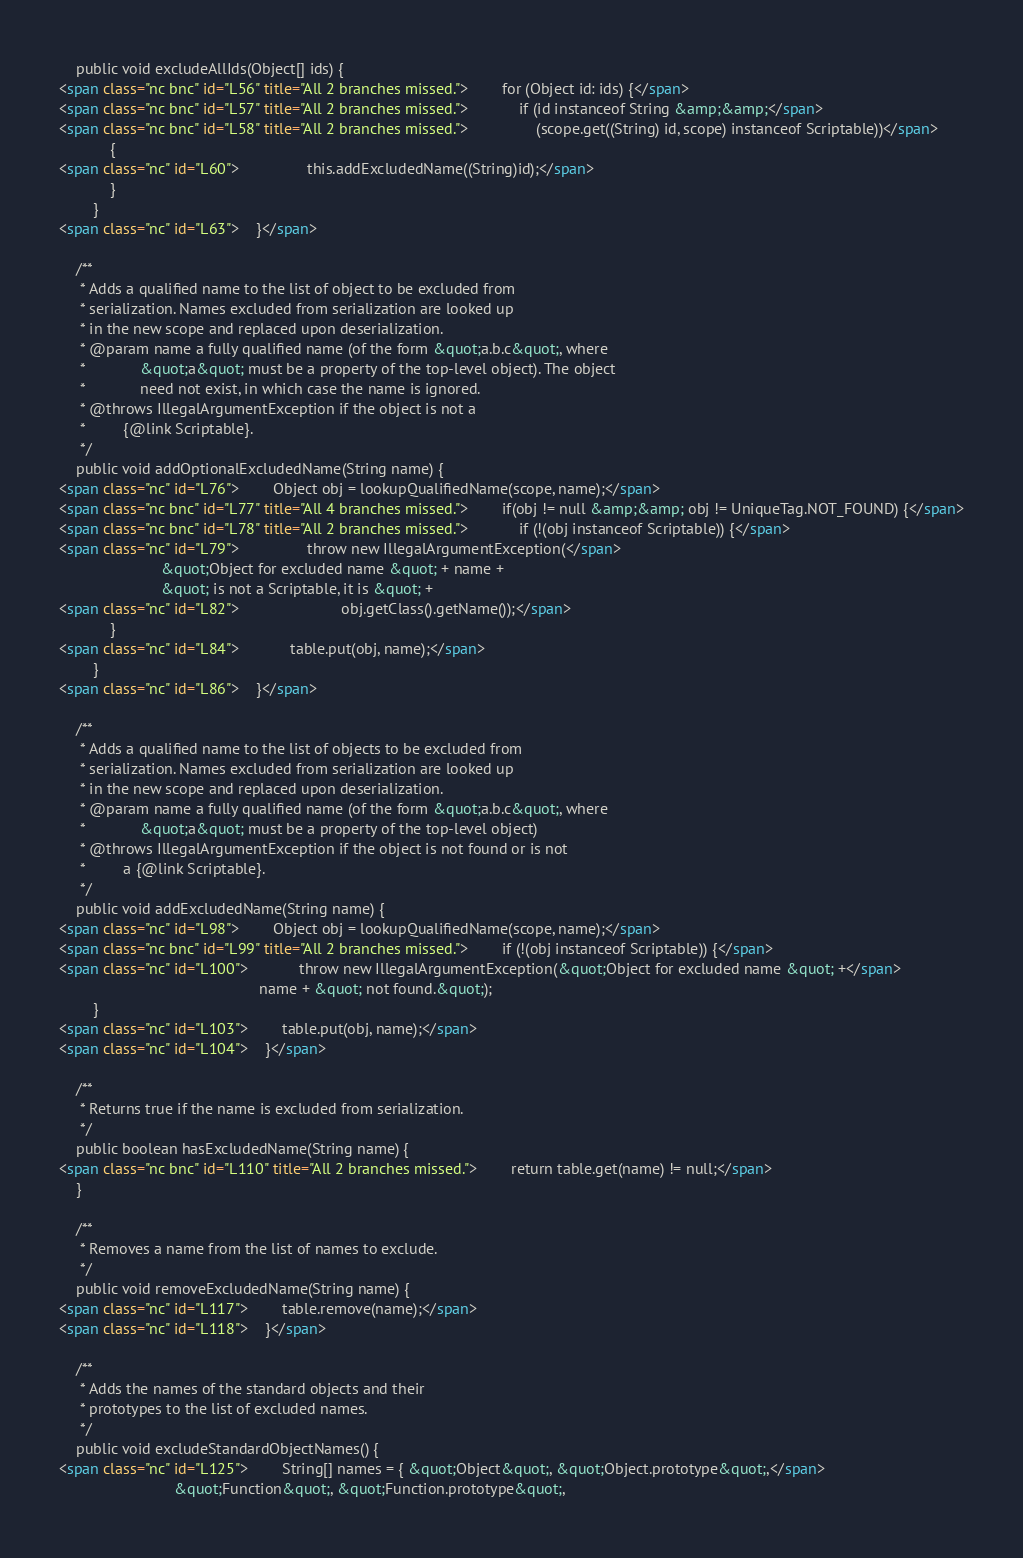<code> <loc_0><loc_0><loc_500><loc_500><_HTML_>    public void excludeAllIds(Object[] ids) {
<span class="nc bnc" id="L56" title="All 2 branches missed.">        for (Object id: ids) {</span>
<span class="nc bnc" id="L57" title="All 2 branches missed.">            if (id instanceof String &amp;&amp;</span>
<span class="nc bnc" id="L58" title="All 2 branches missed.">                (scope.get((String) id, scope) instanceof Scriptable))</span>
            {
<span class="nc" id="L60">                this.addExcludedName((String)id);</span>
            }
        }
<span class="nc" id="L63">    }</span>

    /**
     * Adds a qualified name to the list of object to be excluded from
     * serialization. Names excluded from serialization are looked up
     * in the new scope and replaced upon deserialization.
     * @param name a fully qualified name (of the form &quot;a.b.c&quot;, where
     *             &quot;a&quot; must be a property of the top-level object). The object
     *             need not exist, in which case the name is ignored.
     * @throws IllegalArgumentException if the object is not a
     *         {@link Scriptable}.
     */
    public void addOptionalExcludedName(String name) {
<span class="nc" id="L76">        Object obj = lookupQualifiedName(scope, name);</span>
<span class="nc bnc" id="L77" title="All 4 branches missed.">        if(obj != null &amp;&amp; obj != UniqueTag.NOT_FOUND) {</span>
<span class="nc bnc" id="L78" title="All 2 branches missed.">            if (!(obj instanceof Scriptable)) {</span>
<span class="nc" id="L79">                throw new IllegalArgumentException(</span>
                        &quot;Object for excluded name &quot; + name +
                        &quot; is not a Scriptable, it is &quot; +
<span class="nc" id="L82">                        obj.getClass().getName());</span>
            }
<span class="nc" id="L84">            table.put(obj, name);</span>
        }
<span class="nc" id="L86">    }</span>

    /**
     * Adds a qualified name to the list of objects to be excluded from
     * serialization. Names excluded from serialization are looked up
     * in the new scope and replaced upon deserialization.
     * @param name a fully qualified name (of the form &quot;a.b.c&quot;, where
     *             &quot;a&quot; must be a property of the top-level object)
     * @throws IllegalArgumentException if the object is not found or is not
     *         a {@link Scriptable}.
     */
    public void addExcludedName(String name) {
<span class="nc" id="L98">        Object obj = lookupQualifiedName(scope, name);</span>
<span class="nc bnc" id="L99" title="All 2 branches missed.">        if (!(obj instanceof Scriptable)) {</span>
<span class="nc" id="L100">            throw new IllegalArgumentException(&quot;Object for excluded name &quot; +</span>
                                               name + &quot; not found.&quot;);
        }
<span class="nc" id="L103">        table.put(obj, name);</span>
<span class="nc" id="L104">    }</span>

    /**
     * Returns true if the name is excluded from serialization.
     */
    public boolean hasExcludedName(String name) {
<span class="nc bnc" id="L110" title="All 2 branches missed.">        return table.get(name) != null;</span>
    }

    /**
     * Removes a name from the list of names to exclude.
     */
    public void removeExcludedName(String name) {
<span class="nc" id="L117">        table.remove(name);</span>
<span class="nc" id="L118">    }</span>

    /**
     * Adds the names of the standard objects and their
     * prototypes to the list of excluded names.
     */
    public void excludeStandardObjectNames() {
<span class="nc" id="L125">        String[] names = { &quot;Object&quot;, &quot;Object.prototype&quot;,</span>
                           &quot;Function&quot;, &quot;Function.prototype&quot;,</code> 